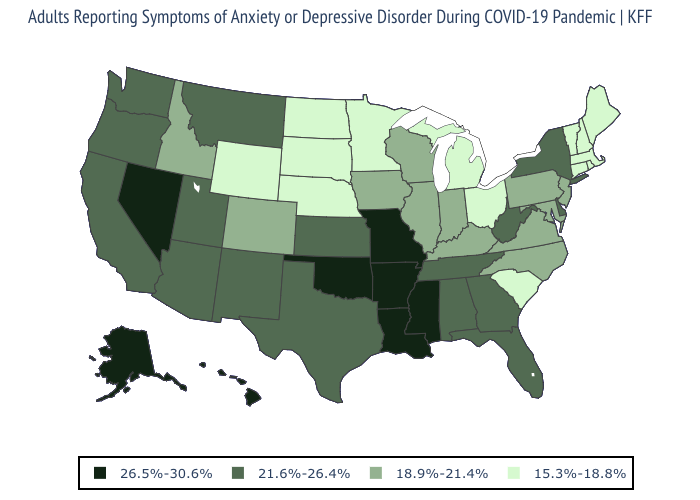Name the states that have a value in the range 21.6%-26.4%?
Keep it brief. Alabama, Arizona, California, Delaware, Florida, Georgia, Kansas, Montana, New Mexico, New York, Oregon, Tennessee, Texas, Utah, Washington, West Virginia. Name the states that have a value in the range 15.3%-18.8%?
Answer briefly. Connecticut, Maine, Massachusetts, Michigan, Minnesota, Nebraska, New Hampshire, North Dakota, Ohio, Rhode Island, South Carolina, South Dakota, Vermont, Wyoming. Is the legend a continuous bar?
Concise answer only. No. What is the lowest value in states that border Texas?
Keep it brief. 21.6%-26.4%. What is the value of Iowa?
Give a very brief answer. 18.9%-21.4%. Name the states that have a value in the range 15.3%-18.8%?
Be succinct. Connecticut, Maine, Massachusetts, Michigan, Minnesota, Nebraska, New Hampshire, North Dakota, Ohio, Rhode Island, South Carolina, South Dakota, Vermont, Wyoming. Name the states that have a value in the range 18.9%-21.4%?
Give a very brief answer. Colorado, Idaho, Illinois, Indiana, Iowa, Kentucky, Maryland, New Jersey, North Carolina, Pennsylvania, Virginia, Wisconsin. Does Alaska have the lowest value in the USA?
Write a very short answer. No. What is the value of New Mexico?
Keep it brief. 21.6%-26.4%. Among the states that border Alabama , which have the highest value?
Short answer required. Mississippi. What is the value of South Dakota?
Answer briefly. 15.3%-18.8%. Does Mississippi have the highest value in the South?
Be succinct. Yes. Among the states that border West Virginia , does Maryland have the lowest value?
Short answer required. No. Name the states that have a value in the range 18.9%-21.4%?
Answer briefly. Colorado, Idaho, Illinois, Indiana, Iowa, Kentucky, Maryland, New Jersey, North Carolina, Pennsylvania, Virginia, Wisconsin. What is the value of Tennessee?
Keep it brief. 21.6%-26.4%. 